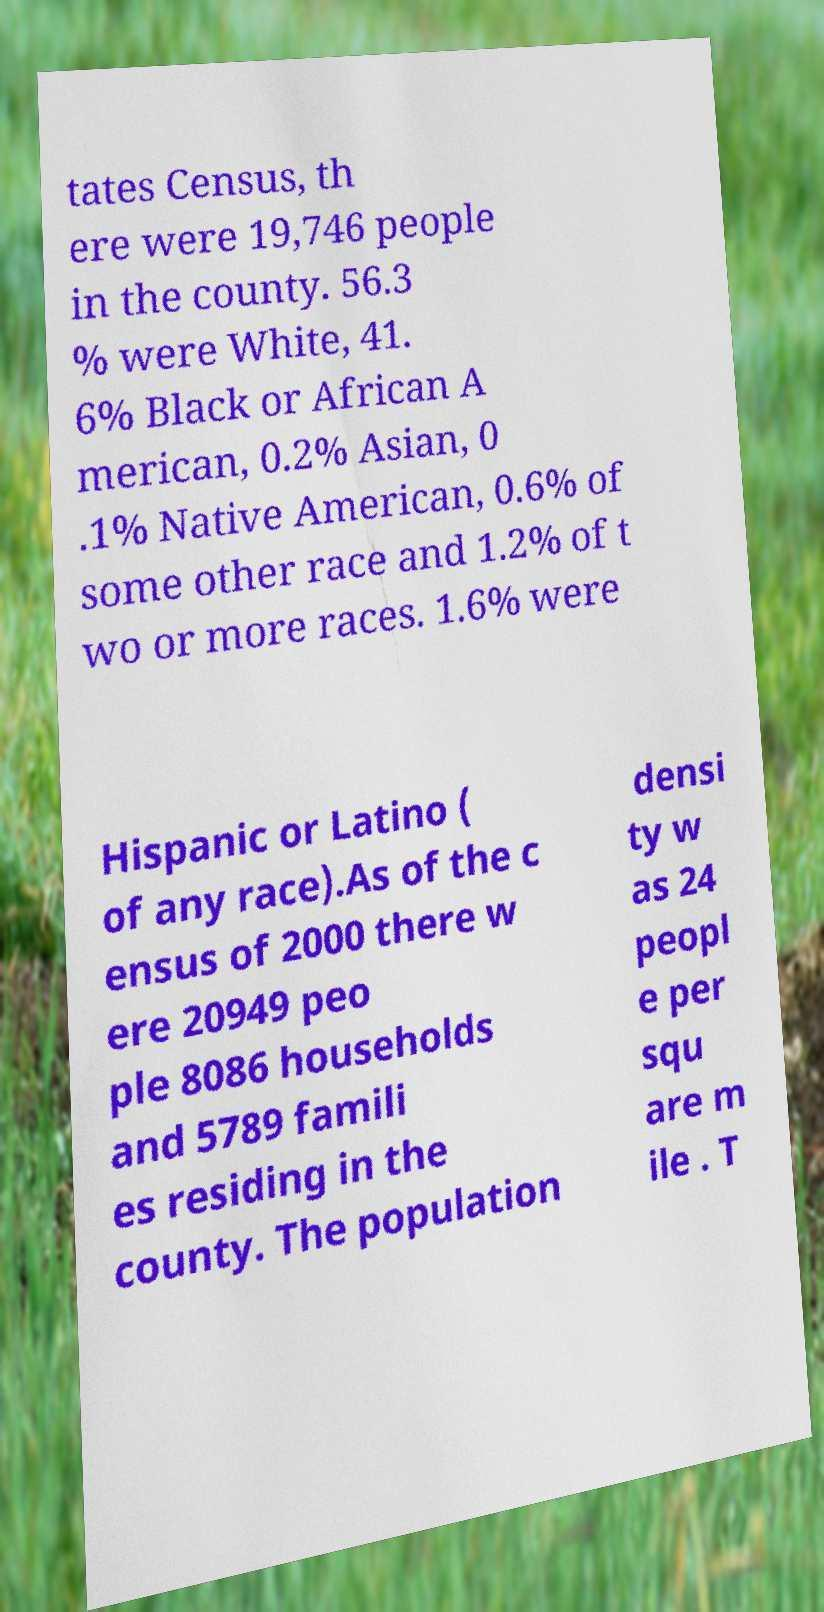Can you accurately transcribe the text from the provided image for me? tates Census, th ere were 19,746 people in the county. 56.3 % were White, 41. 6% Black or African A merican, 0.2% Asian, 0 .1% Native American, 0.6% of some other race and 1.2% of t wo or more races. 1.6% were Hispanic or Latino ( of any race).As of the c ensus of 2000 there w ere 20949 peo ple 8086 households and 5789 famili es residing in the county. The population densi ty w as 24 peopl e per squ are m ile . T 